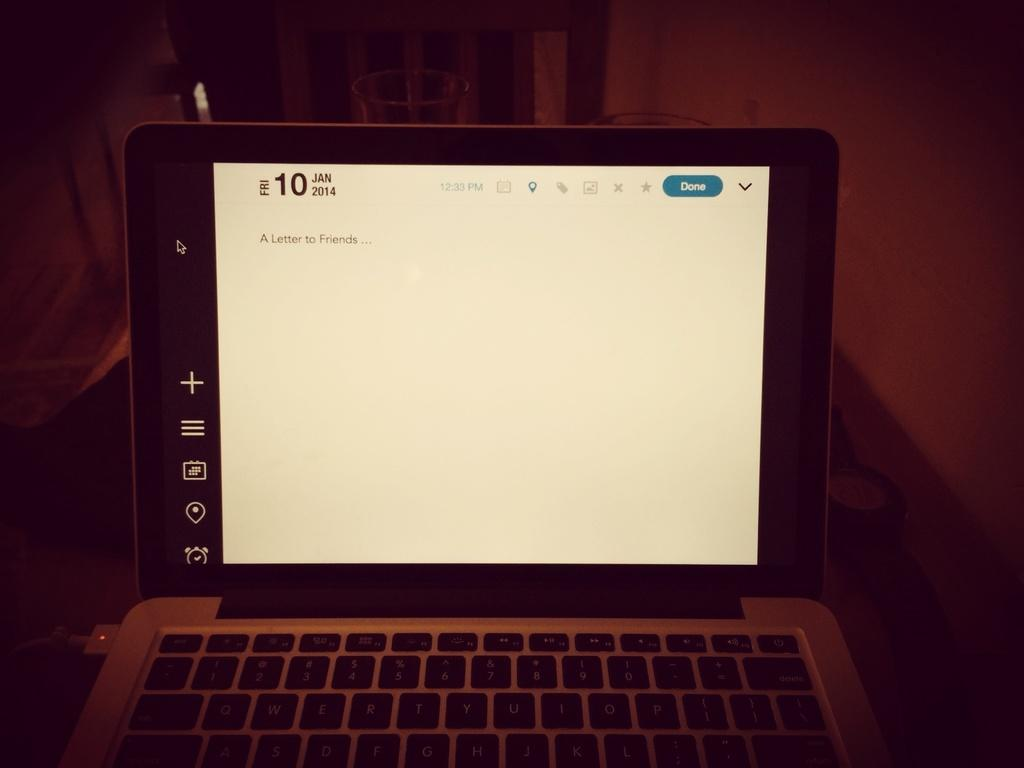Provide a one-sentence caption for the provided image. A computer monitor is lit up with the date 10 Jan 2014 on top. 